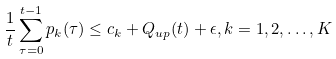Convert formula to latex. <formula><loc_0><loc_0><loc_500><loc_500>\frac { 1 } { t } \sum _ { \tau = 0 } ^ { t - 1 } p _ { k } ( \tau ) \leq c _ { k } + Q _ { u p } ( t ) + \epsilon , k = 1 , 2 , \dots , K</formula> 